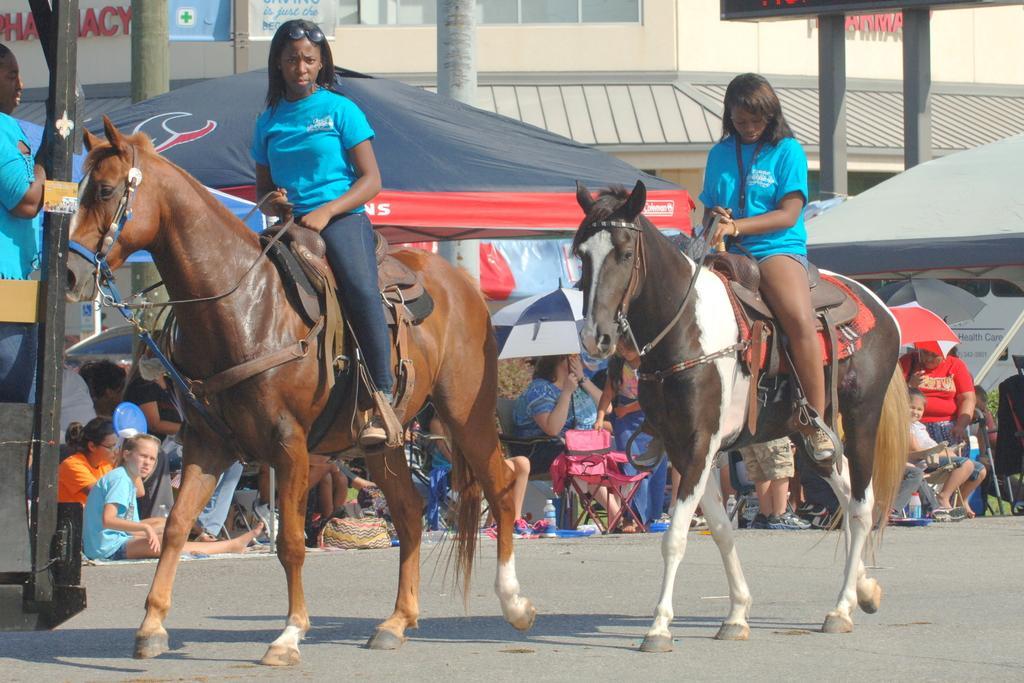In one or two sentences, can you explain what this image depicts? In the image there are two horses. In the right there is a horse on that there is a woman. In the left there is another horse on that there is a woman. In the middle there is a chair. In the middle there is a crowd ,umbrella and tent. In the middle there is a tree and building. 